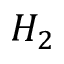Convert formula to latex. <formula><loc_0><loc_0><loc_500><loc_500>H _ { 2 }</formula> 